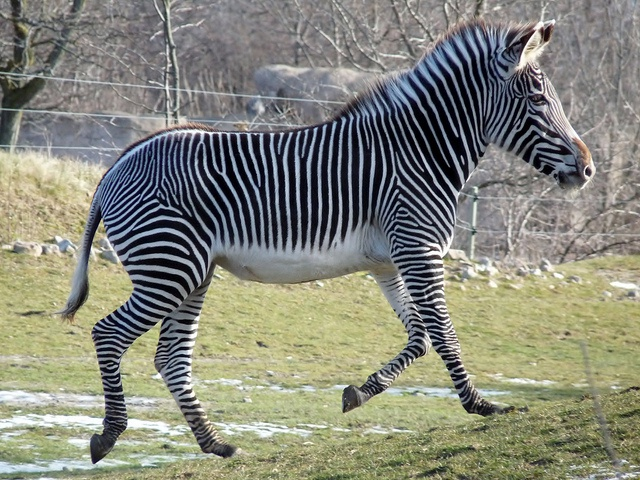Describe the objects in this image and their specific colors. I can see a zebra in gray, black, and darkgray tones in this image. 